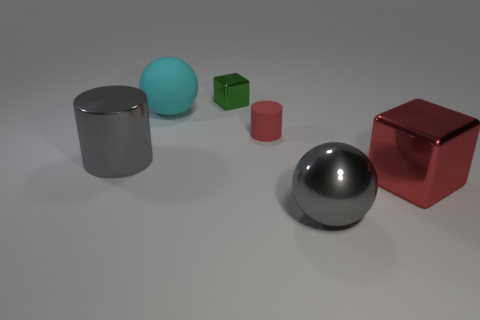Subtract 1 cylinders. How many cylinders are left? 1 Subtract all spheres. How many objects are left? 4 Add 3 large red metallic blocks. How many objects exist? 9 Subtract 0 brown blocks. How many objects are left? 6 Subtract all cyan cylinders. Subtract all gray balls. How many cylinders are left? 2 Subtract all green cubes. How many brown cylinders are left? 0 Subtract all gray shiny things. Subtract all red cubes. How many objects are left? 3 Add 1 cyan objects. How many cyan objects are left? 2 Add 5 small metallic cubes. How many small metallic cubes exist? 6 